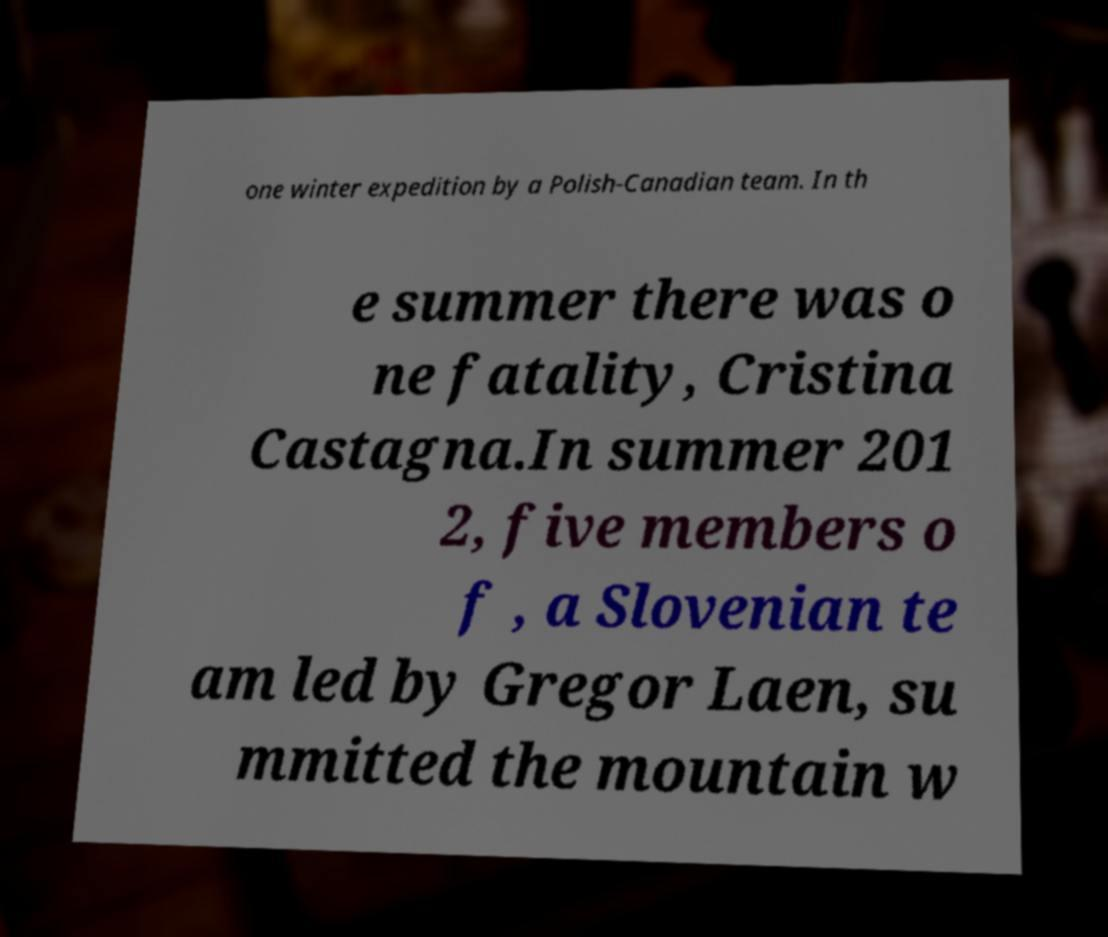I need the written content from this picture converted into text. Can you do that? one winter expedition by a Polish-Canadian team. In th e summer there was o ne fatality, Cristina Castagna.In summer 201 2, five members o f , a Slovenian te am led by Gregor Laen, su mmitted the mountain w 